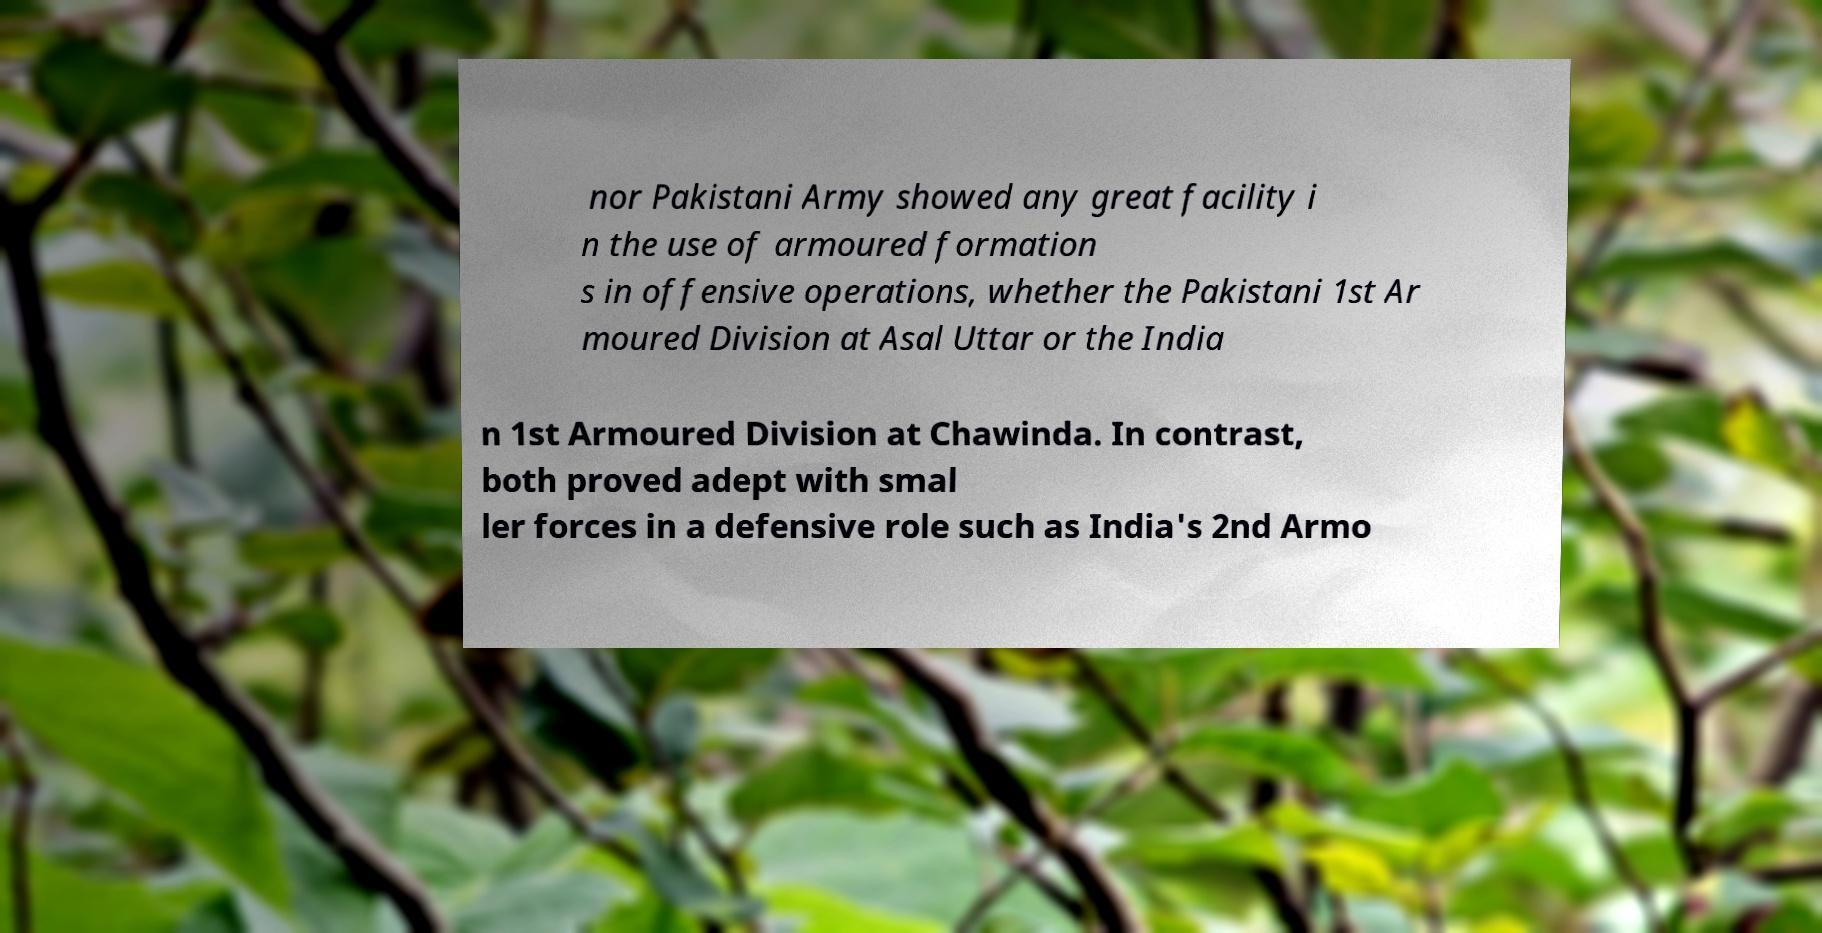I need the written content from this picture converted into text. Can you do that? nor Pakistani Army showed any great facility i n the use of armoured formation s in offensive operations, whether the Pakistani 1st Ar moured Division at Asal Uttar or the India n 1st Armoured Division at Chawinda. In contrast, both proved adept with smal ler forces in a defensive role such as India's 2nd Armo 